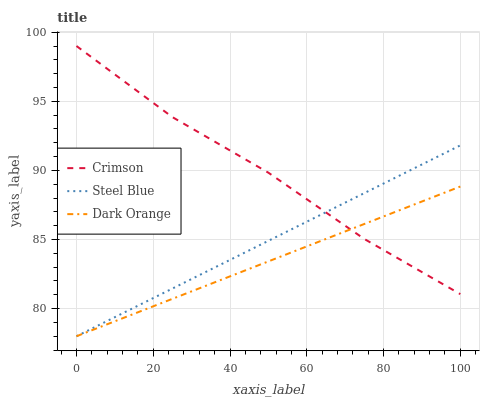Does Dark Orange have the minimum area under the curve?
Answer yes or no. Yes. Does Crimson have the maximum area under the curve?
Answer yes or no. Yes. Does Steel Blue have the minimum area under the curve?
Answer yes or no. No. Does Steel Blue have the maximum area under the curve?
Answer yes or no. No. Is Steel Blue the smoothest?
Answer yes or no. Yes. Is Crimson the roughest?
Answer yes or no. Yes. Is Dark Orange the smoothest?
Answer yes or no. No. Is Dark Orange the roughest?
Answer yes or no. No. Does Crimson have the highest value?
Answer yes or no. Yes. Does Steel Blue have the highest value?
Answer yes or no. No. Does Dark Orange intersect Steel Blue?
Answer yes or no. Yes. Is Dark Orange less than Steel Blue?
Answer yes or no. No. Is Dark Orange greater than Steel Blue?
Answer yes or no. No. 